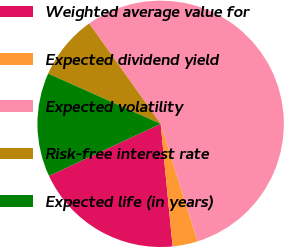Convert chart to OTSL. <chart><loc_0><loc_0><loc_500><loc_500><pie_chart><fcel>Weighted average value for<fcel>Expected dividend yield<fcel>Expected volatility<fcel>Risk-free interest rate<fcel>Expected life (in years)<nl><fcel>19.6%<fcel>3.3%<fcel>55.0%<fcel>8.47%<fcel>13.64%<nl></chart> 